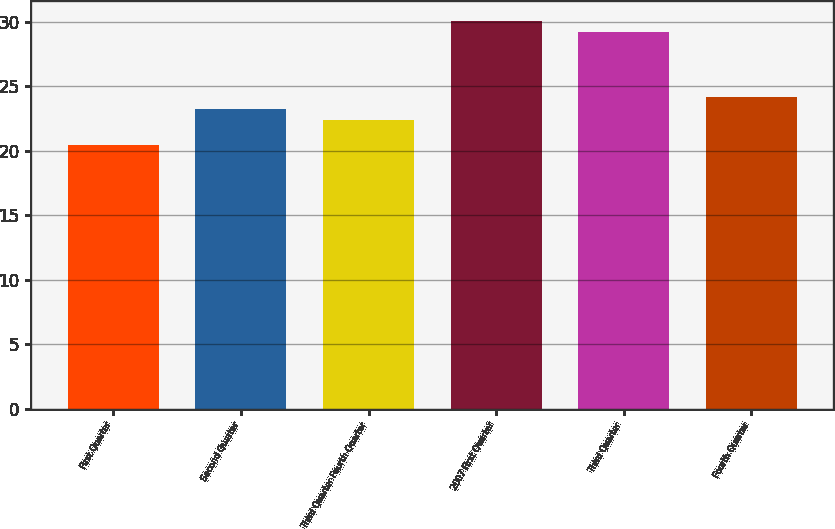Convert chart. <chart><loc_0><loc_0><loc_500><loc_500><bar_chart><fcel>First Quarter<fcel>Second Quarter<fcel>Third Quarter Fourth Quarter<fcel>2007 First Quarter<fcel>Third Quarter<fcel>Fourth Quarter<nl><fcel>20.45<fcel>23.29<fcel>22.37<fcel>30.11<fcel>29.19<fcel>24.21<nl></chart> 